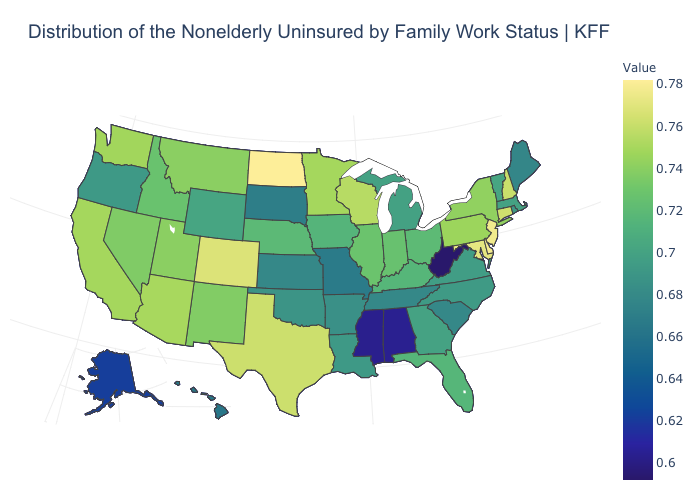Among the states that border New Jersey , which have the lowest value?
Write a very short answer. New York. Does the map have missing data?
Answer briefly. No. Does North Dakota have the highest value in the USA?
Write a very short answer. Yes. Which states have the highest value in the USA?
Keep it brief. North Dakota. Does the map have missing data?
Quick response, please. No. 